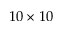Convert formula to latex. <formula><loc_0><loc_0><loc_500><loc_500>1 0 \times 1 0</formula> 